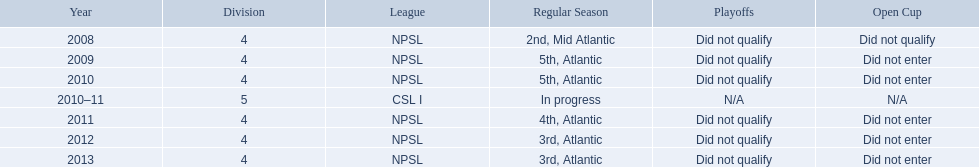In what year only did they compete in division 5 2010-11. 